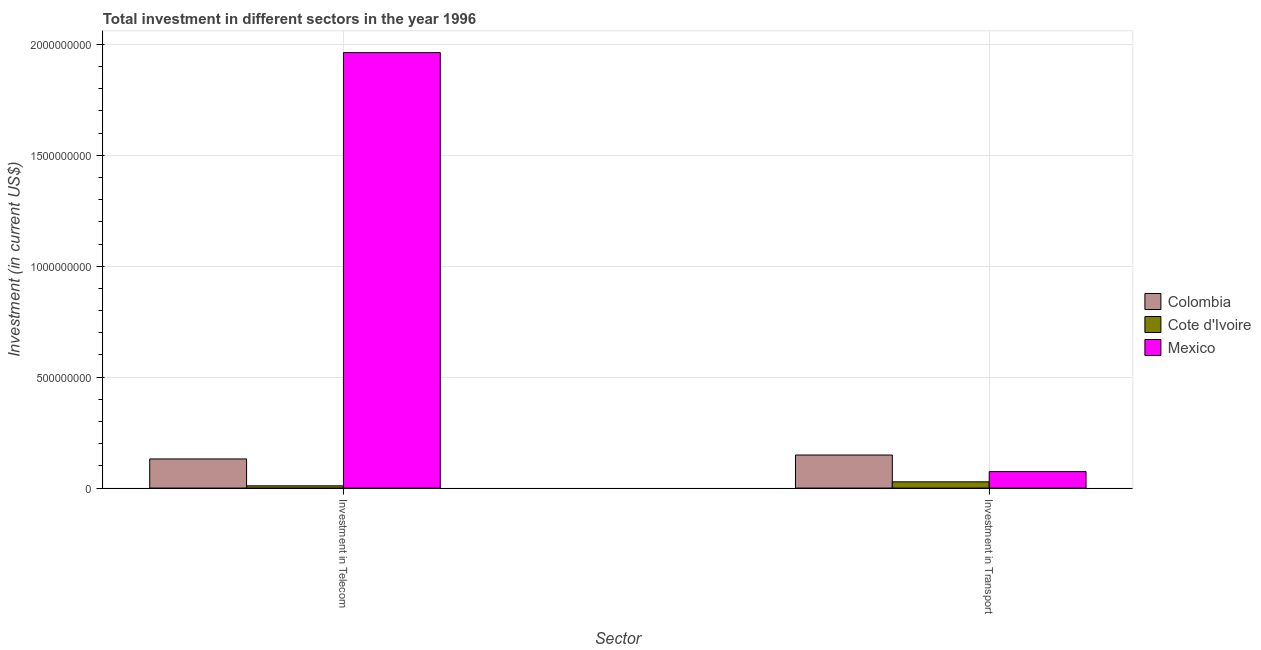How many different coloured bars are there?
Make the answer very short. 3. How many groups of bars are there?
Your answer should be compact. 2. Are the number of bars on each tick of the X-axis equal?
Your response must be concise. Yes. How many bars are there on the 1st tick from the left?
Make the answer very short. 3. What is the label of the 1st group of bars from the left?
Ensure brevity in your answer.  Investment in Telecom. What is the investment in telecom in Cote d'Ivoire?
Keep it short and to the point. 1.00e+07. Across all countries, what is the maximum investment in transport?
Ensure brevity in your answer.  1.49e+08. Across all countries, what is the minimum investment in telecom?
Offer a very short reply. 1.00e+07. In which country was the investment in transport minimum?
Provide a succinct answer. Cote d'Ivoire. What is the total investment in telecom in the graph?
Provide a short and direct response. 2.10e+09. What is the difference between the investment in transport in Colombia and that in Cote d'Ivoire?
Make the answer very short. 1.21e+08. What is the difference between the investment in telecom in Colombia and the investment in transport in Mexico?
Provide a succinct answer. 5.71e+07. What is the average investment in telecom per country?
Make the answer very short. 7.01e+08. What is the difference between the investment in telecom and investment in transport in Cote d'Ivoire?
Your response must be concise. -1.80e+07. In how many countries, is the investment in transport greater than 800000000 US$?
Provide a succinct answer. 0. What is the ratio of the investment in transport in Colombia to that in Cote d'Ivoire?
Provide a short and direct response. 5.32. Is the investment in transport in Cote d'Ivoire less than that in Colombia?
Your answer should be compact. Yes. What does the 2nd bar from the left in Investment in Transport represents?
Keep it short and to the point. Cote d'Ivoire. How many countries are there in the graph?
Ensure brevity in your answer.  3. What is the difference between two consecutive major ticks on the Y-axis?
Ensure brevity in your answer.  5.00e+08. Does the graph contain grids?
Provide a succinct answer. Yes. How many legend labels are there?
Offer a terse response. 3. What is the title of the graph?
Make the answer very short. Total investment in different sectors in the year 1996. What is the label or title of the X-axis?
Offer a very short reply. Sector. What is the label or title of the Y-axis?
Your answer should be compact. Investment (in current US$). What is the Investment (in current US$) of Colombia in Investment in Telecom?
Keep it short and to the point. 1.31e+08. What is the Investment (in current US$) in Mexico in Investment in Telecom?
Provide a short and direct response. 1.96e+09. What is the Investment (in current US$) of Colombia in Investment in Transport?
Ensure brevity in your answer.  1.49e+08. What is the Investment (in current US$) in Cote d'Ivoire in Investment in Transport?
Your answer should be very brief. 2.80e+07. What is the Investment (in current US$) in Mexico in Investment in Transport?
Your answer should be compact. 7.41e+07. Across all Sector, what is the maximum Investment (in current US$) of Colombia?
Provide a succinct answer. 1.49e+08. Across all Sector, what is the maximum Investment (in current US$) in Cote d'Ivoire?
Your answer should be compact. 2.80e+07. Across all Sector, what is the maximum Investment (in current US$) in Mexico?
Give a very brief answer. 1.96e+09. Across all Sector, what is the minimum Investment (in current US$) in Colombia?
Keep it short and to the point. 1.31e+08. Across all Sector, what is the minimum Investment (in current US$) in Cote d'Ivoire?
Offer a terse response. 1.00e+07. Across all Sector, what is the minimum Investment (in current US$) of Mexico?
Your response must be concise. 7.41e+07. What is the total Investment (in current US$) in Colombia in the graph?
Your answer should be compact. 2.80e+08. What is the total Investment (in current US$) in Cote d'Ivoire in the graph?
Offer a terse response. 3.80e+07. What is the total Investment (in current US$) in Mexico in the graph?
Keep it short and to the point. 2.04e+09. What is the difference between the Investment (in current US$) of Colombia in Investment in Telecom and that in Investment in Transport?
Keep it short and to the point. -1.77e+07. What is the difference between the Investment (in current US$) of Cote d'Ivoire in Investment in Telecom and that in Investment in Transport?
Offer a very short reply. -1.80e+07. What is the difference between the Investment (in current US$) in Mexico in Investment in Telecom and that in Investment in Transport?
Your answer should be compact. 1.89e+09. What is the difference between the Investment (in current US$) of Colombia in Investment in Telecom and the Investment (in current US$) of Cote d'Ivoire in Investment in Transport?
Keep it short and to the point. 1.03e+08. What is the difference between the Investment (in current US$) in Colombia in Investment in Telecom and the Investment (in current US$) in Mexico in Investment in Transport?
Give a very brief answer. 5.71e+07. What is the difference between the Investment (in current US$) in Cote d'Ivoire in Investment in Telecom and the Investment (in current US$) in Mexico in Investment in Transport?
Your answer should be very brief. -6.41e+07. What is the average Investment (in current US$) of Colombia per Sector?
Keep it short and to the point. 1.40e+08. What is the average Investment (in current US$) in Cote d'Ivoire per Sector?
Provide a succinct answer. 1.90e+07. What is the average Investment (in current US$) in Mexico per Sector?
Give a very brief answer. 1.02e+09. What is the difference between the Investment (in current US$) in Colombia and Investment (in current US$) in Cote d'Ivoire in Investment in Telecom?
Your answer should be compact. 1.21e+08. What is the difference between the Investment (in current US$) of Colombia and Investment (in current US$) of Mexico in Investment in Telecom?
Provide a succinct answer. -1.83e+09. What is the difference between the Investment (in current US$) in Cote d'Ivoire and Investment (in current US$) in Mexico in Investment in Telecom?
Your answer should be very brief. -1.95e+09. What is the difference between the Investment (in current US$) in Colombia and Investment (in current US$) in Cote d'Ivoire in Investment in Transport?
Make the answer very short. 1.21e+08. What is the difference between the Investment (in current US$) of Colombia and Investment (in current US$) of Mexico in Investment in Transport?
Provide a succinct answer. 7.48e+07. What is the difference between the Investment (in current US$) of Cote d'Ivoire and Investment (in current US$) of Mexico in Investment in Transport?
Ensure brevity in your answer.  -4.61e+07. What is the ratio of the Investment (in current US$) in Colombia in Investment in Telecom to that in Investment in Transport?
Provide a short and direct response. 0.88. What is the ratio of the Investment (in current US$) of Cote d'Ivoire in Investment in Telecom to that in Investment in Transport?
Offer a very short reply. 0.36. What is the ratio of the Investment (in current US$) of Mexico in Investment in Telecom to that in Investment in Transport?
Make the answer very short. 26.49. What is the difference between the highest and the second highest Investment (in current US$) in Colombia?
Provide a short and direct response. 1.77e+07. What is the difference between the highest and the second highest Investment (in current US$) in Cote d'Ivoire?
Make the answer very short. 1.80e+07. What is the difference between the highest and the second highest Investment (in current US$) of Mexico?
Your response must be concise. 1.89e+09. What is the difference between the highest and the lowest Investment (in current US$) of Colombia?
Provide a short and direct response. 1.77e+07. What is the difference between the highest and the lowest Investment (in current US$) of Cote d'Ivoire?
Make the answer very short. 1.80e+07. What is the difference between the highest and the lowest Investment (in current US$) of Mexico?
Your answer should be compact. 1.89e+09. 